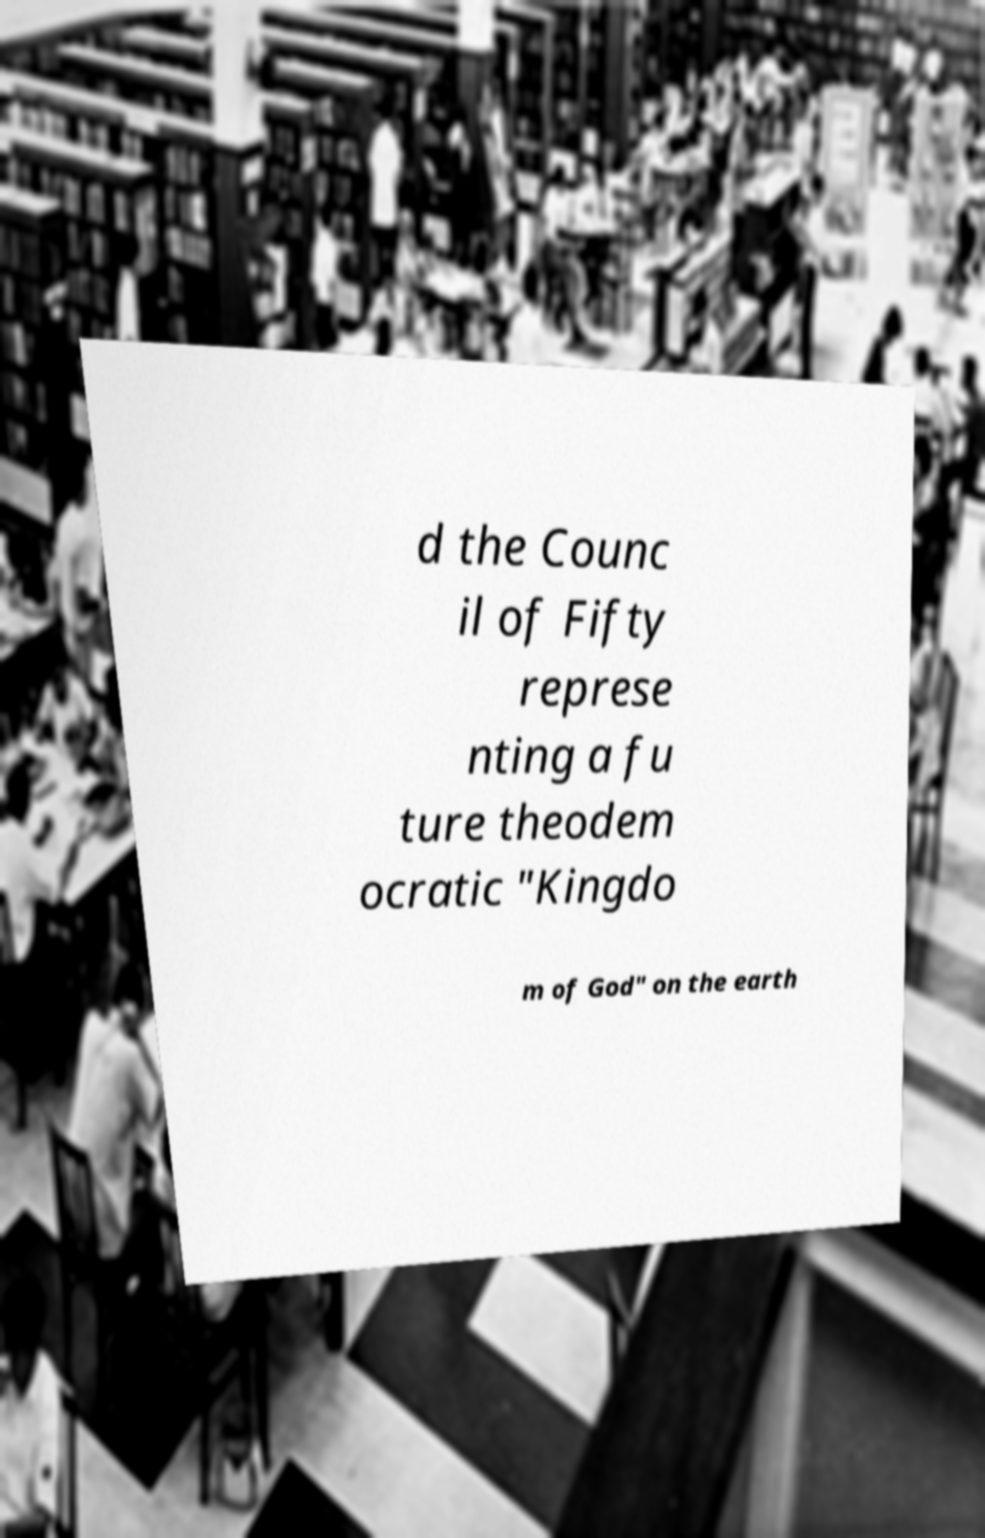Could you extract and type out the text from this image? d the Counc il of Fifty represe nting a fu ture theodem ocratic "Kingdo m of God" on the earth 